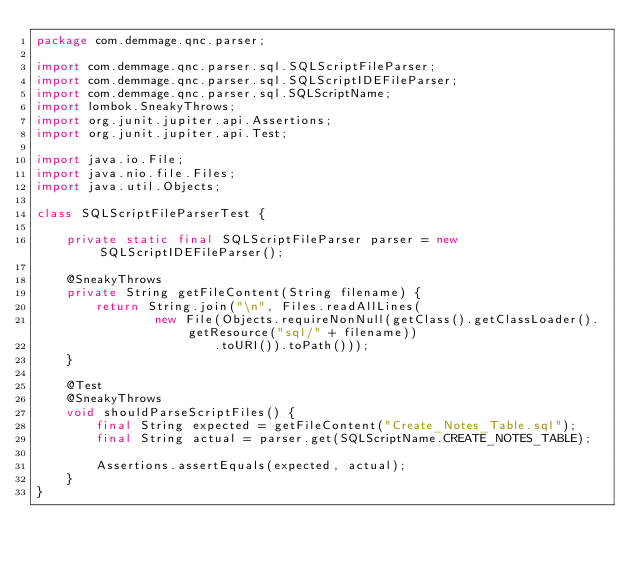Convert code to text. <code><loc_0><loc_0><loc_500><loc_500><_Java_>package com.demmage.qnc.parser;

import com.demmage.qnc.parser.sql.SQLScriptFileParser;
import com.demmage.qnc.parser.sql.SQLScriptIDEFileParser;
import com.demmage.qnc.parser.sql.SQLScriptName;
import lombok.SneakyThrows;
import org.junit.jupiter.api.Assertions;
import org.junit.jupiter.api.Test;

import java.io.File;
import java.nio.file.Files;
import java.util.Objects;

class SQLScriptFileParserTest {

    private static final SQLScriptFileParser parser = new SQLScriptIDEFileParser();

    @SneakyThrows
    private String getFileContent(String filename) {
        return String.join("\n", Files.readAllLines(
                new File(Objects.requireNonNull(getClass().getClassLoader().getResource("sql/" + filename))
                        .toURI()).toPath()));
    }

    @Test
    @SneakyThrows
    void shouldParseScriptFiles() {
        final String expected = getFileContent("Create_Notes_Table.sql");
        final String actual = parser.get(SQLScriptName.CREATE_NOTES_TABLE);

        Assertions.assertEquals(expected, actual);
    }
}</code> 